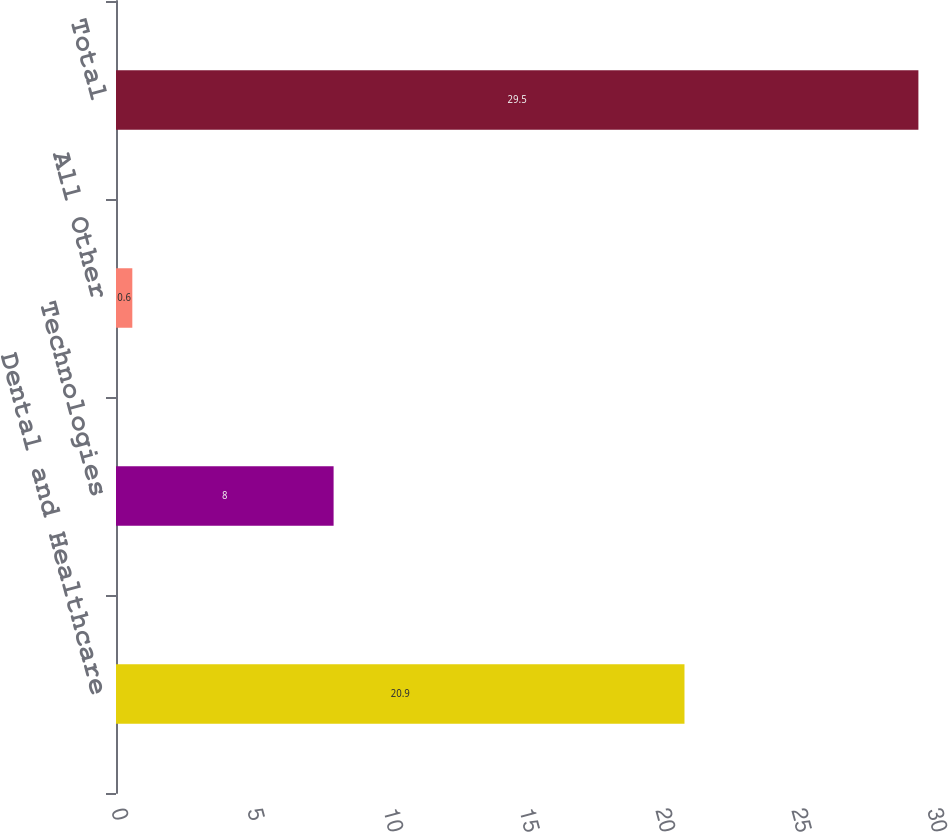<chart> <loc_0><loc_0><loc_500><loc_500><bar_chart><fcel>Dental and Healthcare<fcel>Technologies<fcel>All Other<fcel>Total<nl><fcel>20.9<fcel>8<fcel>0.6<fcel>29.5<nl></chart> 